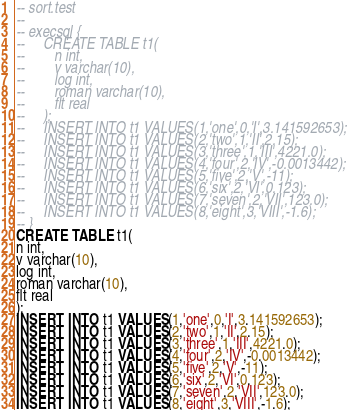Convert code to text. <code><loc_0><loc_0><loc_500><loc_500><_SQL_>-- sort.test
-- 
-- execsql {
--     CREATE TABLE t1(
--        n int,
--        v varchar(10),
--        log int,
--        roman varchar(10),
--        flt real
--     );
--     INSERT INTO t1 VALUES(1,'one',0,'I',3.141592653);
--     INSERT INTO t1 VALUES(2,'two',1,'II',2.15);
--     INSERT INTO t1 VALUES(3,'three',1,'III',4221.0);
--     INSERT INTO t1 VALUES(4,'four',2,'IV',-0.0013442);
--     INSERT INTO t1 VALUES(5,'five',2,'V',-11);
--     INSERT INTO t1 VALUES(6,'six',2,'VI',0.123);
--     INSERT INTO t1 VALUES(7,'seven',2,'VII',123.0);
--     INSERT INTO t1 VALUES(8,'eight',3,'VIII',-1.6);
-- }
CREATE TABLE t1(
n int,
v varchar(10),
log int,
roman varchar(10),
flt real
);
INSERT INTO t1 VALUES(1,'one',0,'I',3.141592653);
INSERT INTO t1 VALUES(2,'two',1,'II',2.15);
INSERT INTO t1 VALUES(3,'three',1,'III',4221.0);
INSERT INTO t1 VALUES(4,'four',2,'IV',-0.0013442);
INSERT INTO t1 VALUES(5,'five',2,'V',-11);
INSERT INTO t1 VALUES(6,'six',2,'VI',0.123);
INSERT INTO t1 VALUES(7,'seven',2,'VII',123.0);
INSERT INTO t1 VALUES(8,'eight',3,'VIII',-1.6);</code> 